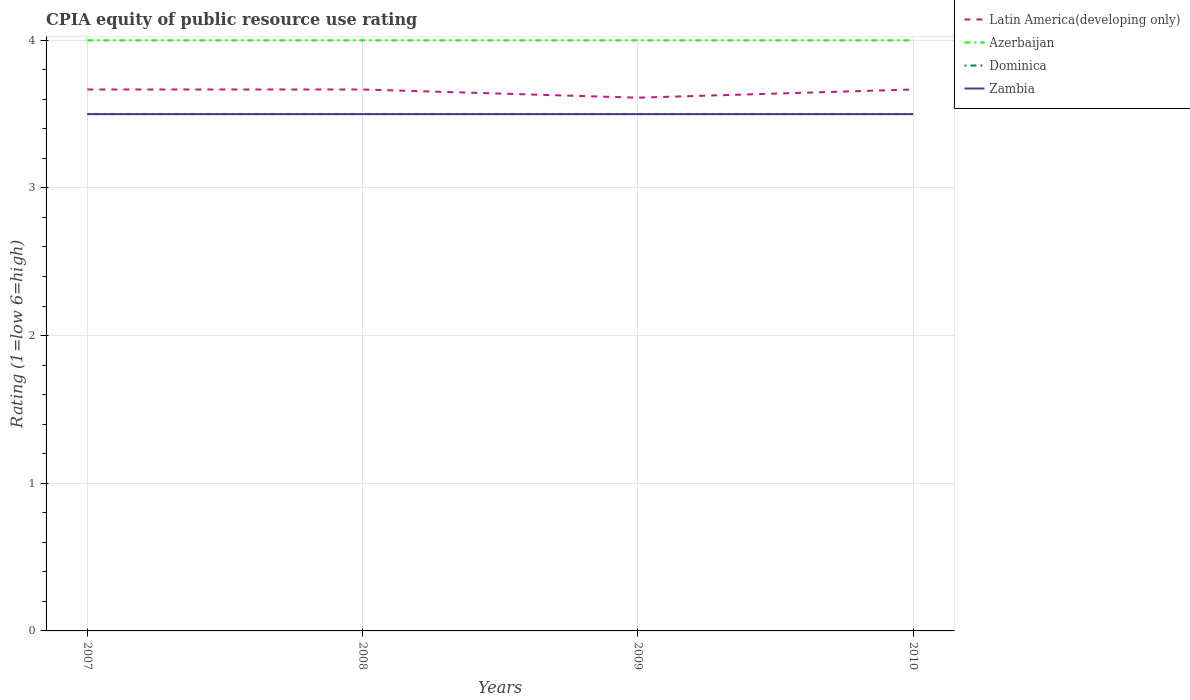Does the line corresponding to Latin America(developing only) intersect with the line corresponding to Zambia?
Provide a short and direct response. No. Is the number of lines equal to the number of legend labels?
Provide a short and direct response. Yes. Is the CPIA rating in Azerbaijan strictly greater than the CPIA rating in Zambia over the years?
Provide a short and direct response. No. How many years are there in the graph?
Make the answer very short. 4. What is the difference between two consecutive major ticks on the Y-axis?
Your response must be concise. 1. Are the values on the major ticks of Y-axis written in scientific E-notation?
Offer a terse response. No. Does the graph contain grids?
Your response must be concise. Yes. Where does the legend appear in the graph?
Your answer should be very brief. Top right. How are the legend labels stacked?
Provide a succinct answer. Vertical. What is the title of the graph?
Keep it short and to the point. CPIA equity of public resource use rating. What is the label or title of the X-axis?
Provide a succinct answer. Years. What is the label or title of the Y-axis?
Your answer should be compact. Rating (1=low 6=high). What is the Rating (1=low 6=high) in Latin America(developing only) in 2007?
Provide a succinct answer. 3.67. What is the Rating (1=low 6=high) in Azerbaijan in 2007?
Provide a succinct answer. 4. What is the Rating (1=low 6=high) of Zambia in 2007?
Make the answer very short. 3.5. What is the Rating (1=low 6=high) in Latin America(developing only) in 2008?
Provide a short and direct response. 3.67. What is the Rating (1=low 6=high) in Azerbaijan in 2008?
Provide a succinct answer. 4. What is the Rating (1=low 6=high) in Dominica in 2008?
Provide a short and direct response. 3.5. What is the Rating (1=low 6=high) of Zambia in 2008?
Your answer should be compact. 3.5. What is the Rating (1=low 6=high) in Latin America(developing only) in 2009?
Offer a terse response. 3.61. What is the Rating (1=low 6=high) in Dominica in 2009?
Keep it short and to the point. 3.5. What is the Rating (1=low 6=high) in Latin America(developing only) in 2010?
Give a very brief answer. 3.67. What is the Rating (1=low 6=high) of Azerbaijan in 2010?
Make the answer very short. 4. What is the Rating (1=low 6=high) in Dominica in 2010?
Offer a terse response. 3.5. Across all years, what is the maximum Rating (1=low 6=high) in Latin America(developing only)?
Make the answer very short. 3.67. Across all years, what is the maximum Rating (1=low 6=high) of Azerbaijan?
Keep it short and to the point. 4. Across all years, what is the maximum Rating (1=low 6=high) of Zambia?
Your response must be concise. 3.5. Across all years, what is the minimum Rating (1=low 6=high) of Latin America(developing only)?
Give a very brief answer. 3.61. Across all years, what is the minimum Rating (1=low 6=high) of Zambia?
Your answer should be very brief. 3.5. What is the total Rating (1=low 6=high) of Latin America(developing only) in the graph?
Offer a very short reply. 14.61. What is the total Rating (1=low 6=high) in Dominica in the graph?
Provide a succinct answer. 14. What is the difference between the Rating (1=low 6=high) of Latin America(developing only) in 2007 and that in 2008?
Give a very brief answer. 0. What is the difference between the Rating (1=low 6=high) of Azerbaijan in 2007 and that in 2008?
Your answer should be very brief. 0. What is the difference between the Rating (1=low 6=high) in Dominica in 2007 and that in 2008?
Offer a terse response. 0. What is the difference between the Rating (1=low 6=high) of Latin America(developing only) in 2007 and that in 2009?
Offer a very short reply. 0.06. What is the difference between the Rating (1=low 6=high) of Azerbaijan in 2007 and that in 2009?
Give a very brief answer. 0. What is the difference between the Rating (1=low 6=high) in Latin America(developing only) in 2007 and that in 2010?
Offer a terse response. 0. What is the difference between the Rating (1=low 6=high) in Zambia in 2007 and that in 2010?
Make the answer very short. 0. What is the difference between the Rating (1=low 6=high) of Latin America(developing only) in 2008 and that in 2009?
Provide a short and direct response. 0.06. What is the difference between the Rating (1=low 6=high) of Azerbaijan in 2008 and that in 2009?
Your answer should be compact. 0. What is the difference between the Rating (1=low 6=high) of Dominica in 2008 and that in 2009?
Provide a succinct answer. 0. What is the difference between the Rating (1=low 6=high) in Zambia in 2008 and that in 2009?
Offer a terse response. 0. What is the difference between the Rating (1=low 6=high) of Latin America(developing only) in 2008 and that in 2010?
Provide a succinct answer. 0. What is the difference between the Rating (1=low 6=high) of Azerbaijan in 2008 and that in 2010?
Offer a terse response. 0. What is the difference between the Rating (1=low 6=high) of Dominica in 2008 and that in 2010?
Ensure brevity in your answer.  0. What is the difference between the Rating (1=low 6=high) of Zambia in 2008 and that in 2010?
Provide a short and direct response. 0. What is the difference between the Rating (1=low 6=high) in Latin America(developing only) in 2009 and that in 2010?
Ensure brevity in your answer.  -0.06. What is the difference between the Rating (1=low 6=high) in Zambia in 2009 and that in 2010?
Provide a short and direct response. 0. What is the difference between the Rating (1=low 6=high) in Latin America(developing only) in 2007 and the Rating (1=low 6=high) in Azerbaijan in 2008?
Provide a short and direct response. -0.33. What is the difference between the Rating (1=low 6=high) in Latin America(developing only) in 2007 and the Rating (1=low 6=high) in Azerbaijan in 2009?
Keep it short and to the point. -0.33. What is the difference between the Rating (1=low 6=high) of Azerbaijan in 2007 and the Rating (1=low 6=high) of Dominica in 2009?
Make the answer very short. 0.5. What is the difference between the Rating (1=low 6=high) of Dominica in 2007 and the Rating (1=low 6=high) of Zambia in 2009?
Ensure brevity in your answer.  0. What is the difference between the Rating (1=low 6=high) of Latin America(developing only) in 2007 and the Rating (1=low 6=high) of Azerbaijan in 2010?
Make the answer very short. -0.33. What is the difference between the Rating (1=low 6=high) in Latin America(developing only) in 2007 and the Rating (1=low 6=high) in Dominica in 2010?
Give a very brief answer. 0.17. What is the difference between the Rating (1=low 6=high) of Azerbaijan in 2007 and the Rating (1=low 6=high) of Zambia in 2010?
Your answer should be compact. 0.5. What is the difference between the Rating (1=low 6=high) in Latin America(developing only) in 2008 and the Rating (1=low 6=high) in Azerbaijan in 2009?
Your answer should be very brief. -0.33. What is the difference between the Rating (1=low 6=high) in Azerbaijan in 2008 and the Rating (1=low 6=high) in Zambia in 2009?
Make the answer very short. 0.5. What is the difference between the Rating (1=low 6=high) of Azerbaijan in 2008 and the Rating (1=low 6=high) of Zambia in 2010?
Your answer should be compact. 0.5. What is the difference between the Rating (1=low 6=high) of Dominica in 2008 and the Rating (1=low 6=high) of Zambia in 2010?
Keep it short and to the point. 0. What is the difference between the Rating (1=low 6=high) in Latin America(developing only) in 2009 and the Rating (1=low 6=high) in Azerbaijan in 2010?
Provide a succinct answer. -0.39. What is the difference between the Rating (1=low 6=high) of Latin America(developing only) in 2009 and the Rating (1=low 6=high) of Dominica in 2010?
Keep it short and to the point. 0.11. What is the difference between the Rating (1=low 6=high) of Azerbaijan in 2009 and the Rating (1=low 6=high) of Dominica in 2010?
Your answer should be very brief. 0.5. What is the difference between the Rating (1=low 6=high) in Dominica in 2009 and the Rating (1=low 6=high) in Zambia in 2010?
Keep it short and to the point. 0. What is the average Rating (1=low 6=high) of Latin America(developing only) per year?
Your answer should be compact. 3.65. What is the average Rating (1=low 6=high) in Dominica per year?
Provide a succinct answer. 3.5. In the year 2007, what is the difference between the Rating (1=low 6=high) of Azerbaijan and Rating (1=low 6=high) of Zambia?
Your answer should be very brief. 0.5. In the year 2007, what is the difference between the Rating (1=low 6=high) in Dominica and Rating (1=low 6=high) in Zambia?
Offer a terse response. 0. In the year 2008, what is the difference between the Rating (1=low 6=high) in Latin America(developing only) and Rating (1=low 6=high) in Azerbaijan?
Give a very brief answer. -0.33. In the year 2008, what is the difference between the Rating (1=low 6=high) of Latin America(developing only) and Rating (1=low 6=high) of Dominica?
Your response must be concise. 0.17. In the year 2008, what is the difference between the Rating (1=low 6=high) in Azerbaijan and Rating (1=low 6=high) in Dominica?
Your response must be concise. 0.5. In the year 2008, what is the difference between the Rating (1=low 6=high) in Dominica and Rating (1=low 6=high) in Zambia?
Your answer should be compact. 0. In the year 2009, what is the difference between the Rating (1=low 6=high) in Latin America(developing only) and Rating (1=low 6=high) in Azerbaijan?
Provide a short and direct response. -0.39. In the year 2009, what is the difference between the Rating (1=low 6=high) of Azerbaijan and Rating (1=low 6=high) of Zambia?
Provide a succinct answer. 0.5. In the year 2010, what is the difference between the Rating (1=low 6=high) of Latin America(developing only) and Rating (1=low 6=high) of Dominica?
Provide a succinct answer. 0.17. In the year 2010, what is the difference between the Rating (1=low 6=high) of Latin America(developing only) and Rating (1=low 6=high) of Zambia?
Provide a short and direct response. 0.17. What is the ratio of the Rating (1=low 6=high) in Latin America(developing only) in 2007 to that in 2008?
Your answer should be compact. 1. What is the ratio of the Rating (1=low 6=high) in Azerbaijan in 2007 to that in 2008?
Offer a very short reply. 1. What is the ratio of the Rating (1=low 6=high) in Zambia in 2007 to that in 2008?
Your response must be concise. 1. What is the ratio of the Rating (1=low 6=high) of Latin America(developing only) in 2007 to that in 2009?
Give a very brief answer. 1.02. What is the ratio of the Rating (1=low 6=high) in Azerbaijan in 2007 to that in 2009?
Your response must be concise. 1. What is the ratio of the Rating (1=low 6=high) of Dominica in 2007 to that in 2009?
Provide a succinct answer. 1. What is the ratio of the Rating (1=low 6=high) in Zambia in 2007 to that in 2009?
Provide a succinct answer. 1. What is the ratio of the Rating (1=low 6=high) in Latin America(developing only) in 2007 to that in 2010?
Provide a succinct answer. 1. What is the ratio of the Rating (1=low 6=high) of Latin America(developing only) in 2008 to that in 2009?
Give a very brief answer. 1.02. What is the ratio of the Rating (1=low 6=high) in Azerbaijan in 2008 to that in 2009?
Give a very brief answer. 1. What is the ratio of the Rating (1=low 6=high) in Dominica in 2008 to that in 2009?
Make the answer very short. 1. What is the ratio of the Rating (1=low 6=high) in Zambia in 2008 to that in 2009?
Offer a very short reply. 1. What is the ratio of the Rating (1=low 6=high) of Dominica in 2008 to that in 2010?
Provide a short and direct response. 1. What is the ratio of the Rating (1=low 6=high) of Dominica in 2009 to that in 2010?
Offer a terse response. 1. What is the ratio of the Rating (1=low 6=high) in Zambia in 2009 to that in 2010?
Offer a very short reply. 1. What is the difference between the highest and the second highest Rating (1=low 6=high) in Latin America(developing only)?
Your answer should be very brief. 0. What is the difference between the highest and the second highest Rating (1=low 6=high) in Azerbaijan?
Your answer should be very brief. 0. What is the difference between the highest and the second highest Rating (1=low 6=high) in Dominica?
Keep it short and to the point. 0. What is the difference between the highest and the second highest Rating (1=low 6=high) in Zambia?
Keep it short and to the point. 0. What is the difference between the highest and the lowest Rating (1=low 6=high) in Latin America(developing only)?
Provide a succinct answer. 0.06. What is the difference between the highest and the lowest Rating (1=low 6=high) in Azerbaijan?
Give a very brief answer. 0. What is the difference between the highest and the lowest Rating (1=low 6=high) of Dominica?
Offer a terse response. 0. 